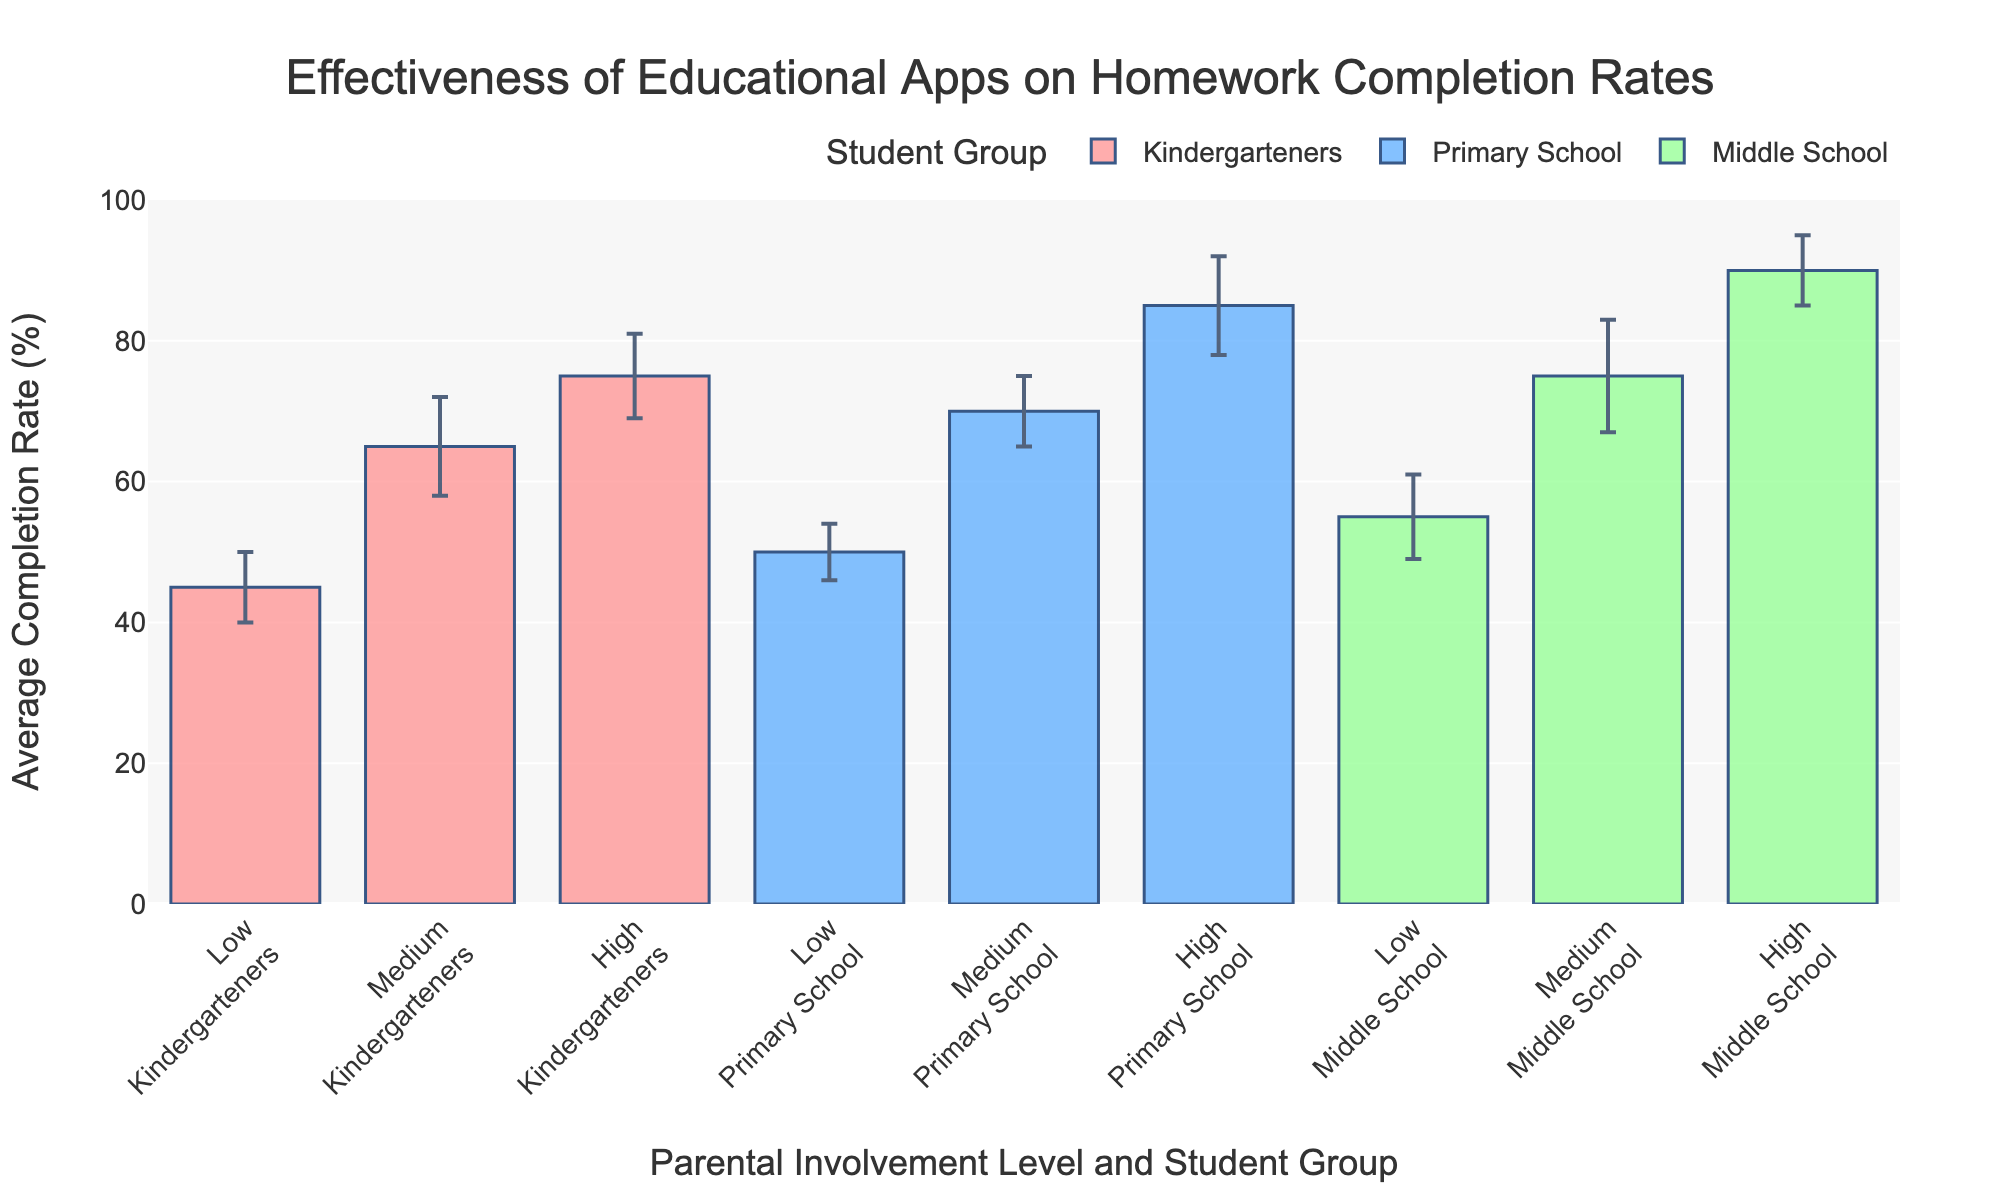What is the title of the bar chart? The title is displayed at the top of the chart. It states the main topic of the data visualization.
Answer: Effectiveness of Educational Apps on Homework Completion Rates Which student group has the highest homework completion rate with medium parental involvement? Look for the medium parental involvement category and compare the bars among the different student groups. The highest bar will indicate the group with the highest completion rate.
Answer: Middle School What is the completion rate for Kindergarteners with low parental involvement? Find the bar representing Kindergarteners under the low parental involvement section. The height of this bar gives the average completion rate.
Answer: 45% How does the completion rate for Primary School students with high parental involvement compare to that of Middle School students with medium parental involvement? Compare the heights of the two specific bars: Primary School with high involvement and Middle School with medium involvement. Identify which is higher.
Answer: Primary School High (85%) is less than Middle School Medium (75%) Which parental involvement level shows the greatest improvement in completion rate for Kindergarteners? Compare the differences in average completion rates between low, medium, and high parental involvement levels for Kindergarteners. Calculate the changes to identify which level shows the greatest improvement.
Answer: Medium to High (10%) What is the difference in completion rates between high parental involvement for Primary School and Kindergarteners? Subtract the completion rate of Kindergarteners from that of Primary School in the high parental involvement category.
Answer: 85% - 75% = 10% What is the error margin for Middle School students with low parental involvement? Look for the error bar information provided for Middle School students with low parental involvement to determine the standard deviation.
Answer: 6% How much higher is the homework completion rate for Primary School students with medium parental involvement compared to low parental involvement? Subtract the completion rate of low parental involvement from medium parental involvement for Primary School students.
Answer: 70% - 50% = 20% Which student group and parental involvement level combination has the largest error bar? Identify the longest error bar across all combinations of student groups and parental involvement levels.
Answer: Middle School with Medium involvement (8%) Between Kindergarteners and Primary School students, which group shows a higher completion rate at low parental involvement levels? Compare the bars representing Kindergarteners and Primary School students under the low parental involvement category. Identify which bar is higher.
Answer: Primary School (50%) 